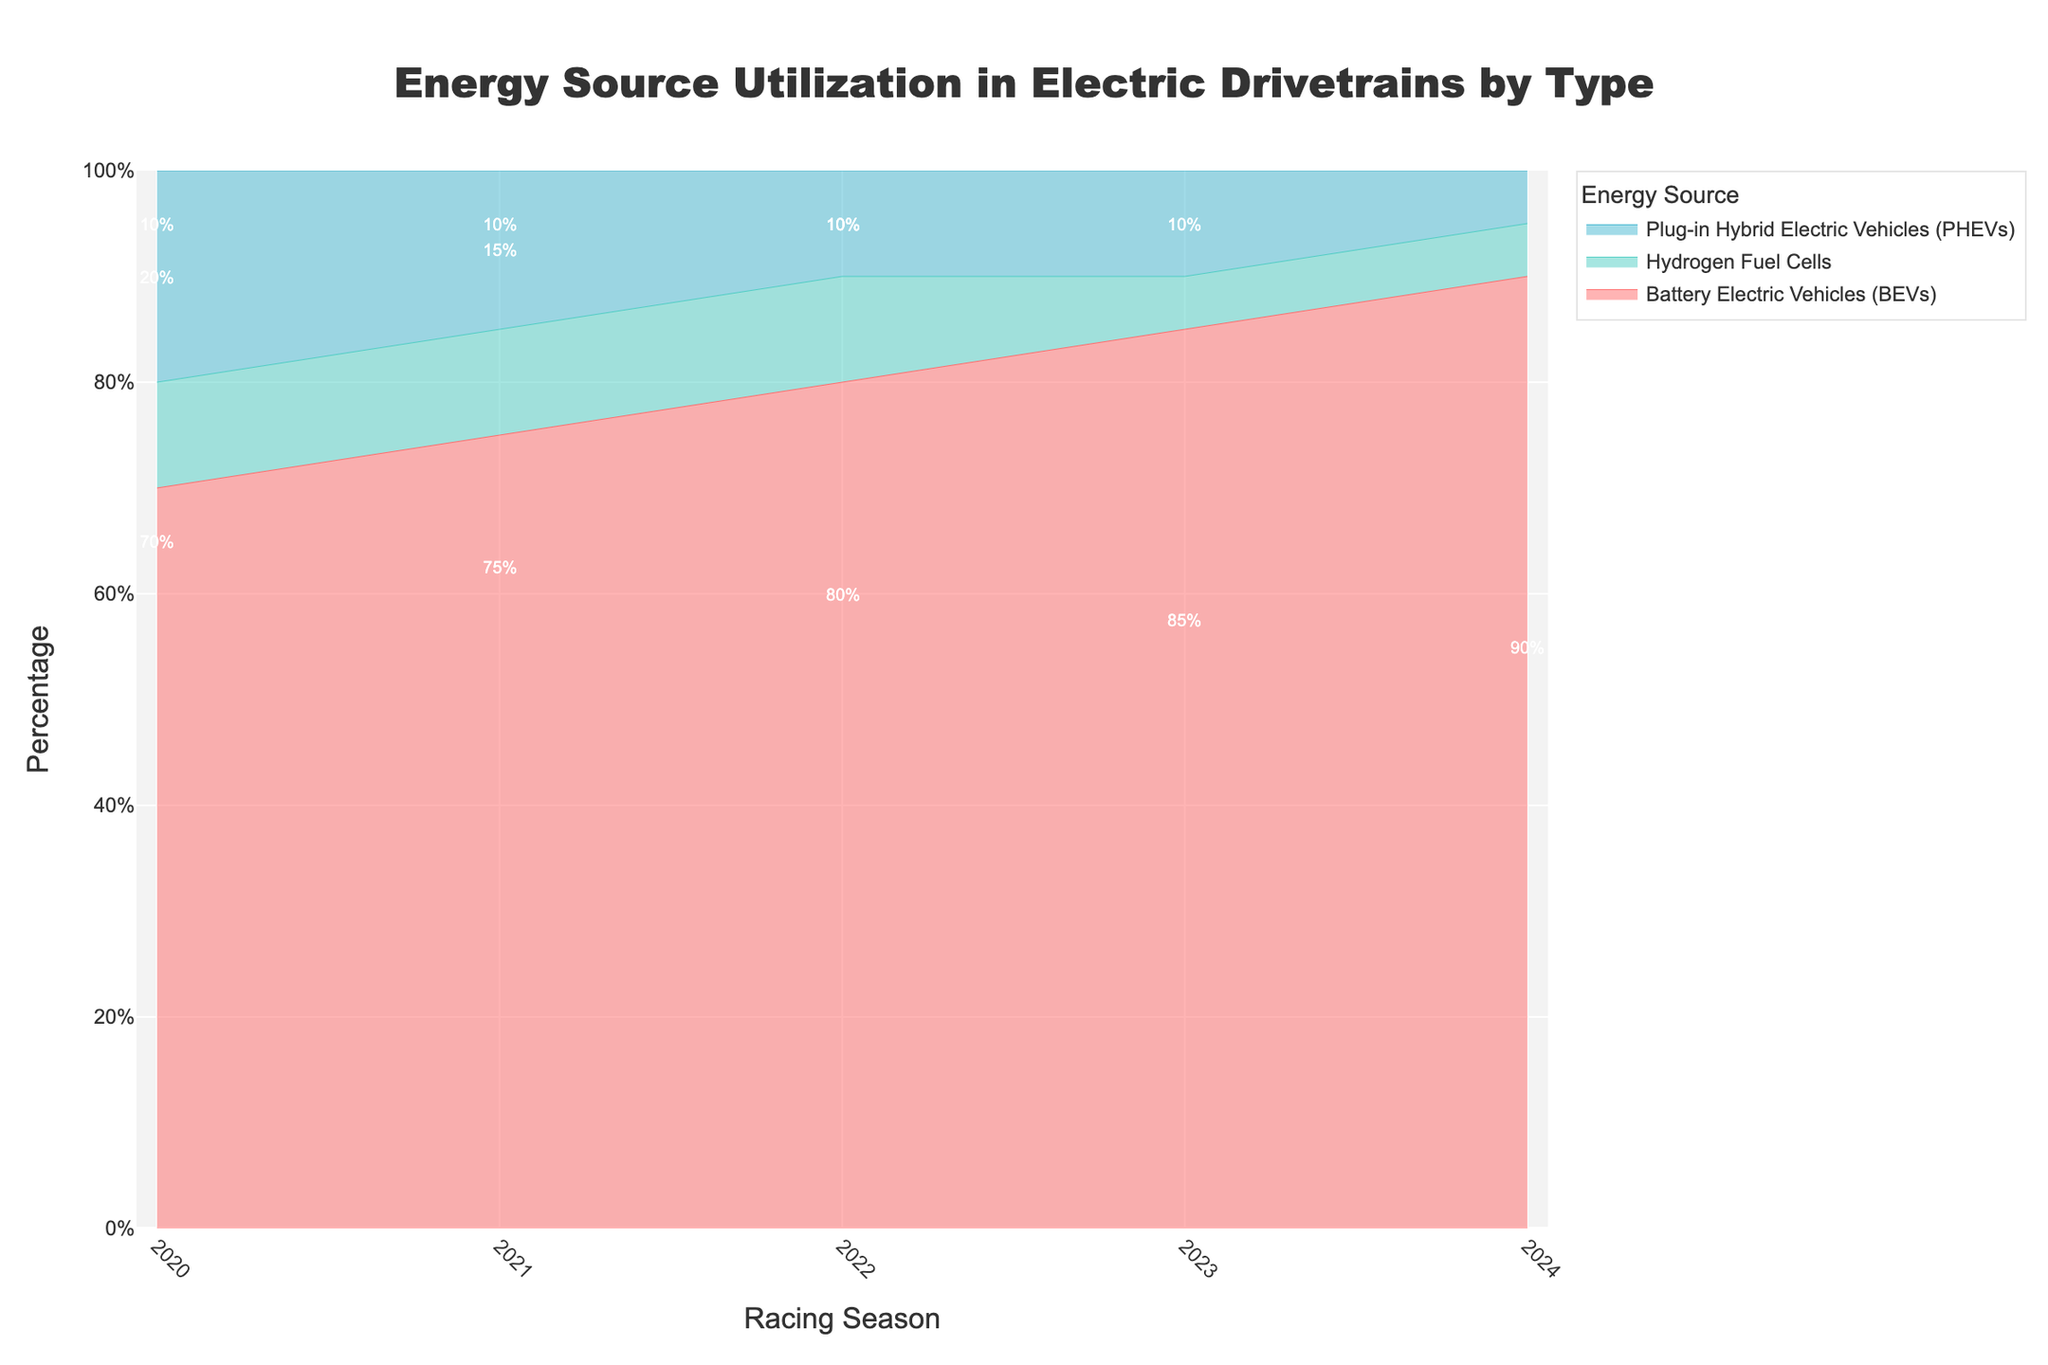What is the title of the chart? The title of the chart is typically shown at the top of the figure.
Answer: Energy Source Utilization in Electric Drivetrains by Type Which energy source had the highest utilization in 2022? Look at the 2022 column and identify the energy source with the largest percentage value.
Answer: Battery Electric Vehicles (BEVs) How does the utilization percentage of Hydrogen Fuel Cells change from 2023 to 2024? Compare the percentage values of Hydrogen Fuel Cells between 2023 and 2024, and notice any difference.
Answer: It decreased from 10% to 5% What is the totalling percentage of Plug-in Hybrid Electric Vehicles (PHEVs) for the year 2021 and 2023? Add the percentage values of PHEVs for 2021 and 2023.
Answer: 15 + 10 = 25% Which season had the lowest percentage of PHEVs? Identify the season with the smallest value in the PHEVs category.
Answer: 2024 Compare the change in percentage utilization of BEVs between 2020 and 2024. Subtract the percentage of BEVs in 2020 from the percentage of BEVs in 2024.
Answer: 90% - 70% = 20% In which year does the utilization of BEVs surpass 75%? Review the BEV percentages across the seasons and identify the first year it exceeds 75%.
Answer: 2021 What is the average percentage of Hydrogen Fuel Cells across all the seasons? Add the percentage values of Hydrogen Fuel Cells for all the seasons and divide by the number of seasons (5).
Answer: (10 + 10 + 10 + 5 + 5) / 5 = 8% Which energy source shows a steady increase over the years? Evaluate the trend of each energy source over the seasons to find a consistent upward progression.
Answer: Battery Electric Vehicles (BEVs) How much did the proportion of PHEVs decrease from 2020 to 2024? Subtract the percentage of PHEVs in 2024 from the percentage of PHEVs in 2020.
Answer: 20% - 5% = 15% 